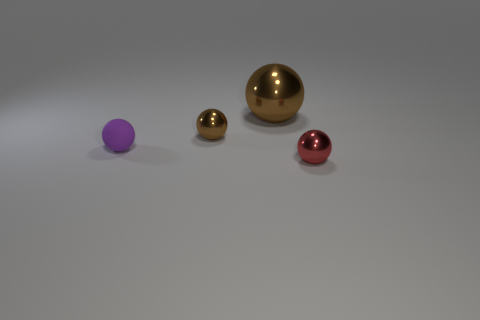Subtract all metallic balls. How many balls are left? 1 Subtract 2 spheres. How many spheres are left? 2 Add 3 red spheres. How many objects exist? 7 Subtract all cyan spheres. Subtract all green blocks. How many spheres are left? 4 Add 1 small brown shiny things. How many small brown shiny things exist? 2 Subtract 0 blue spheres. How many objects are left? 4 Subtract all big spheres. Subtract all small brown spheres. How many objects are left? 2 Add 4 small purple matte balls. How many small purple matte balls are left? 5 